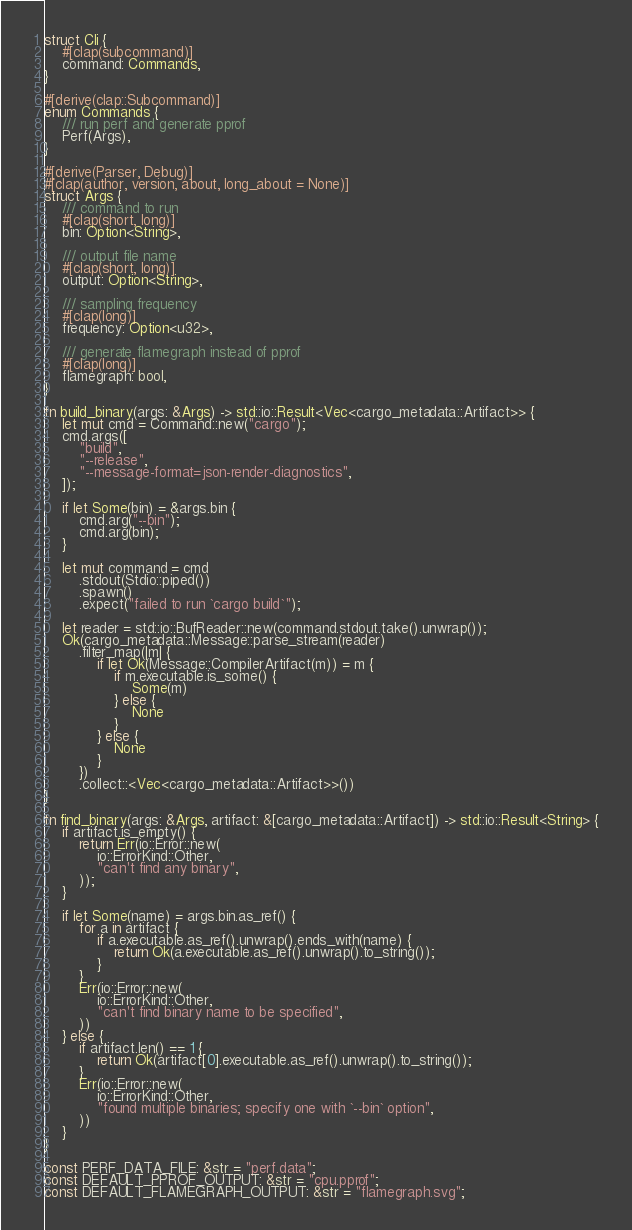<code> <loc_0><loc_0><loc_500><loc_500><_Rust_>struct Cli {
    #[clap(subcommand)]
    command: Commands,
}

#[derive(clap::Subcommand)]
enum Commands {
    /// run perf and generate pprof
    Perf(Args),
}

#[derive(Parser, Debug)]
#[clap(author, version, about, long_about = None)]
struct Args {
    /// command to run
    #[clap(short, long)]
    bin: Option<String>,

    /// output file name
    #[clap(short, long)]
    output: Option<String>,

    /// sampling frequency
    #[clap(long)]
    frequency: Option<u32>,

    /// generate flamegraph instead of pprof
    #[clap(long)]
    flamegraph: bool,
}

fn build_binary(args: &Args) -> std::io::Result<Vec<cargo_metadata::Artifact>> {
    let mut cmd = Command::new("cargo");
    cmd.args([
        "build",
        "--release",
        "--message-format=json-render-diagnostics",
    ]);

    if let Some(bin) = &args.bin {
        cmd.arg("--bin");
        cmd.arg(bin);
    }

    let mut command = cmd
        .stdout(Stdio::piped())
        .spawn()
        .expect("failed to run `cargo build`");

    let reader = std::io::BufReader::new(command.stdout.take().unwrap());
    Ok(cargo_metadata::Message::parse_stream(reader)
        .filter_map(|m| {
            if let Ok(Message::CompilerArtifact(m)) = m {
                if m.executable.is_some() {
                    Some(m)
                } else {
                    None
                }
            } else {
                None
            }
        })
        .collect::<Vec<cargo_metadata::Artifact>>())
}

fn find_binary(args: &Args, artifact: &[cargo_metadata::Artifact]) -> std::io::Result<String> {
    if artifact.is_empty() {
        return Err(io::Error::new(
            io::ErrorKind::Other,
            "can't find any binary",
        ));
    }

    if let Some(name) = args.bin.as_ref() {
        for a in artifact {
            if a.executable.as_ref().unwrap().ends_with(name) {
                return Ok(a.executable.as_ref().unwrap().to_string());
            }
        }
        Err(io::Error::new(
            io::ErrorKind::Other,
            "can't find binary name to be specified",
        ))
    } else {
        if artifact.len() == 1 {
            return Ok(artifact[0].executable.as_ref().unwrap().to_string());
        }
        Err(io::Error::new(
            io::ErrorKind::Other,
            "found multiple binaries; specify one with `--bin` option",
        ))
    }
}

const PERF_DATA_FILE: &str = "perf.data";
const DEFAULT_PPROF_OUTPUT: &str = "cpu.pprof";
const DEFAULT_FLAMEGRAPH_OUTPUT: &str = "flamegraph.svg";</code> 